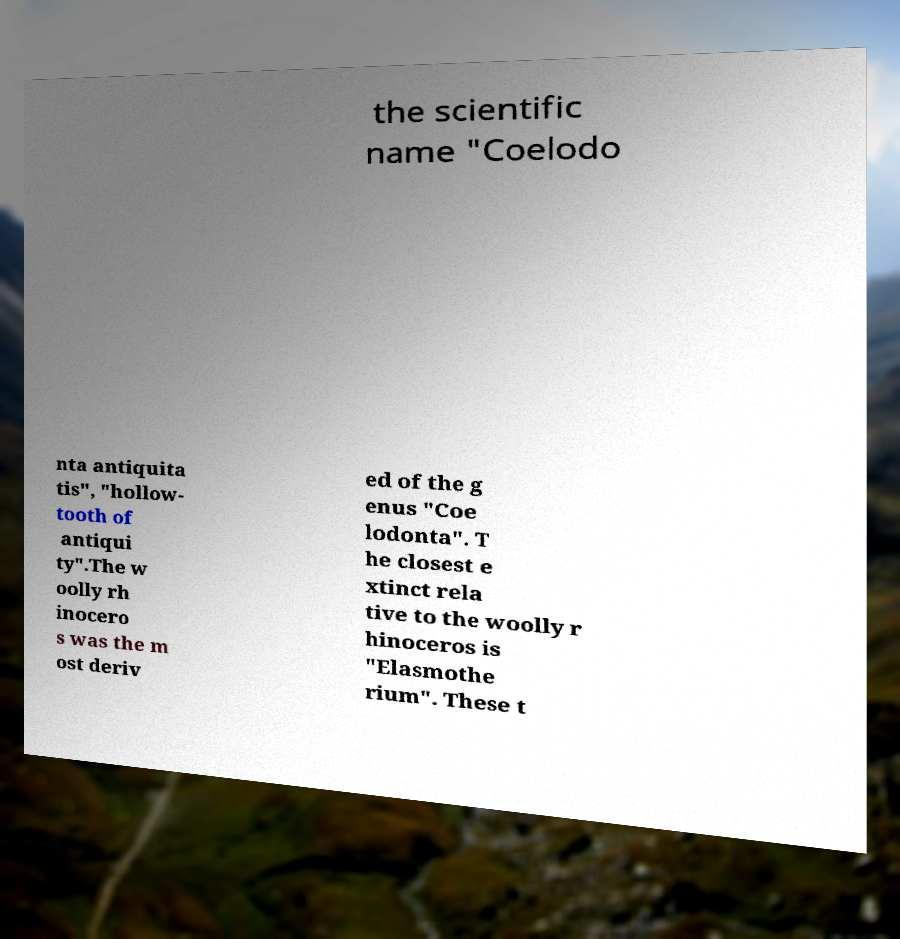Could you extract and type out the text from this image? the scientific name "Coelodo nta antiquita tis", "hollow- tooth of antiqui ty".The w oolly rh inocero s was the m ost deriv ed of the g enus "Coe lodonta". T he closest e xtinct rela tive to the woolly r hinoceros is "Elasmothe rium". These t 